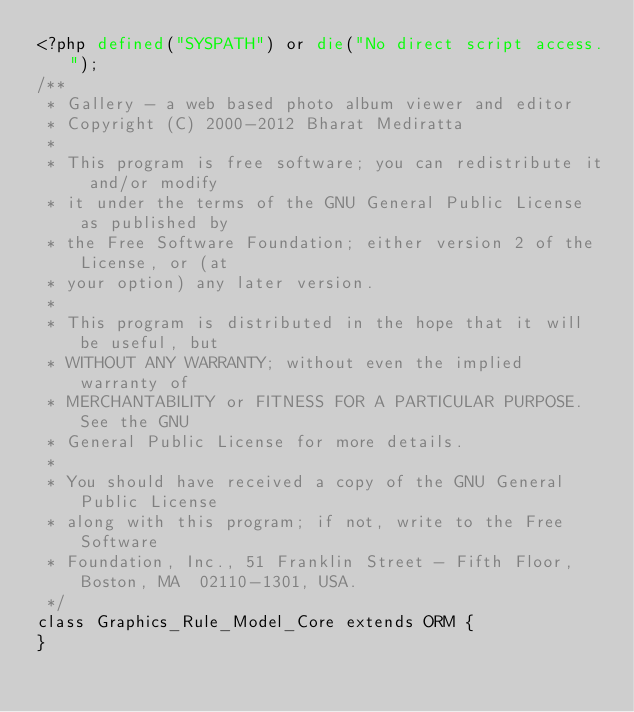<code> <loc_0><loc_0><loc_500><loc_500><_PHP_><?php defined("SYSPATH") or die("No direct script access.");
/**
 * Gallery - a web based photo album viewer and editor
 * Copyright (C) 2000-2012 Bharat Mediratta
 *
 * This program is free software; you can redistribute it and/or modify
 * it under the terms of the GNU General Public License as published by
 * the Free Software Foundation; either version 2 of the License, or (at
 * your option) any later version.
 *
 * This program is distributed in the hope that it will be useful, but
 * WITHOUT ANY WARRANTY; without even the implied warranty of
 * MERCHANTABILITY or FITNESS FOR A PARTICULAR PURPOSE.  See the GNU
 * General Public License for more details.
 *
 * You should have received a copy of the GNU General Public License
 * along with this program; if not, write to the Free Software
 * Foundation, Inc., 51 Franklin Street - Fifth Floor, Boston, MA  02110-1301, USA.
 */
class Graphics_Rule_Model_Core extends ORM {
}
</code> 